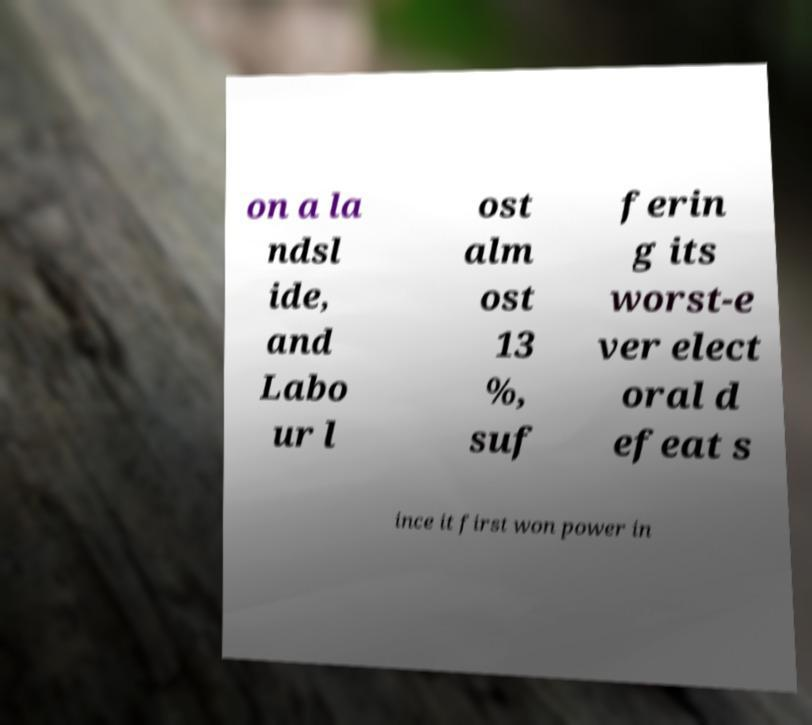Please read and relay the text visible in this image. What does it say? on a la ndsl ide, and Labo ur l ost alm ost 13 %, suf ferin g its worst-e ver elect oral d efeat s ince it first won power in 